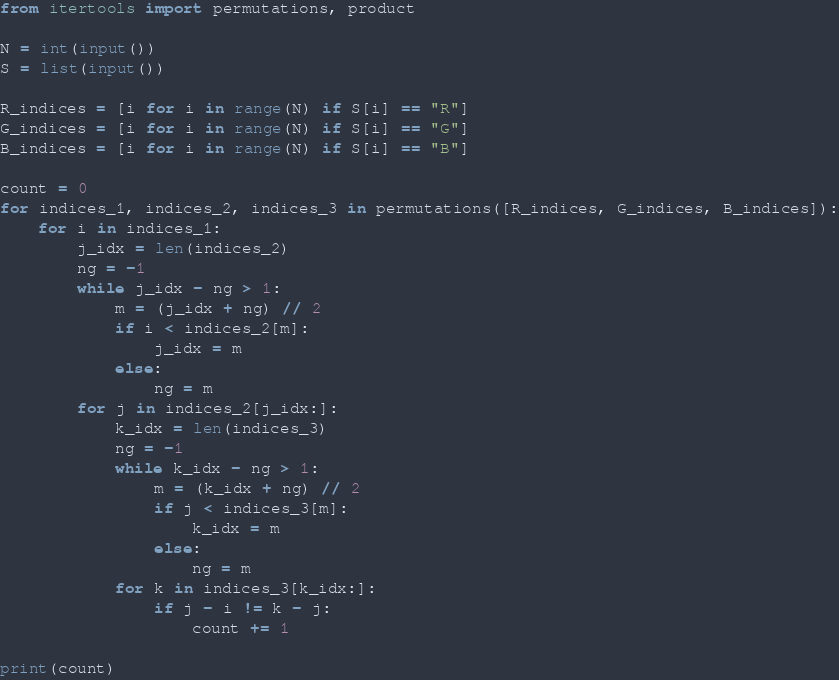<code> <loc_0><loc_0><loc_500><loc_500><_Python_>from itertools import permutations, product

N = int(input())
S = list(input())

R_indices = [i for i in range(N) if S[i] == "R"]
G_indices = [i for i in range(N) if S[i] == "G"]
B_indices = [i for i in range(N) if S[i] == "B"]

count = 0
for indices_1, indices_2, indices_3 in permutations([R_indices, G_indices, B_indices]):
    for i in indices_1:
        j_idx = len(indices_2)
        ng = -1
        while j_idx - ng > 1:
            m = (j_idx + ng) // 2
            if i < indices_2[m]:
                j_idx = m
            else:
                ng = m
        for j in indices_2[j_idx:]:
            k_idx = len(indices_3)
            ng = -1
            while k_idx - ng > 1:
                m = (k_idx + ng) // 2
                if j < indices_3[m]:
                    k_idx = m
                else:
                    ng = m
            for k in indices_3[k_idx:]:
                if j - i != k - j:
                    count += 1

print(count)</code> 